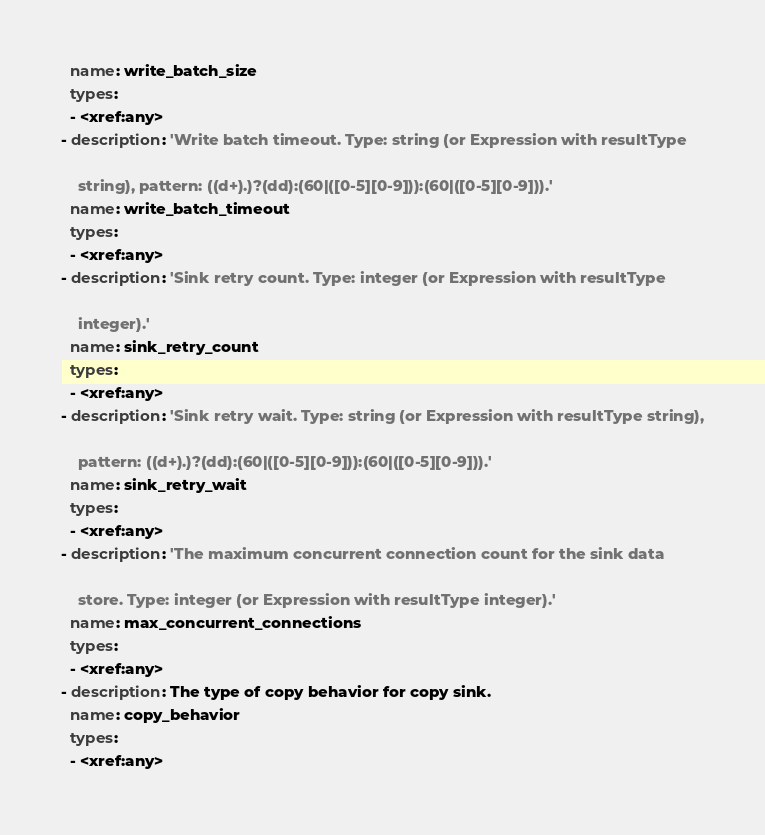Convert code to text. <code><loc_0><loc_0><loc_500><loc_500><_YAML_>  name: write_batch_size
  types:
  - <xref:any>
- description: 'Write batch timeout. Type: string (or Expression with resultType

    string), pattern: ((d+).)?(dd):(60|([0-5][0-9])):(60|([0-5][0-9])).'
  name: write_batch_timeout
  types:
  - <xref:any>
- description: 'Sink retry count. Type: integer (or Expression with resultType

    integer).'
  name: sink_retry_count
  types:
  - <xref:any>
- description: 'Sink retry wait. Type: string (or Expression with resultType string),

    pattern: ((d+).)?(dd):(60|([0-5][0-9])):(60|([0-5][0-9])).'
  name: sink_retry_wait
  types:
  - <xref:any>
- description: 'The maximum concurrent connection count for the sink data

    store. Type: integer (or Expression with resultType integer).'
  name: max_concurrent_connections
  types:
  - <xref:any>
- description: The type of copy behavior for copy sink.
  name: copy_behavior
  types:
  - <xref:any>
</code> 